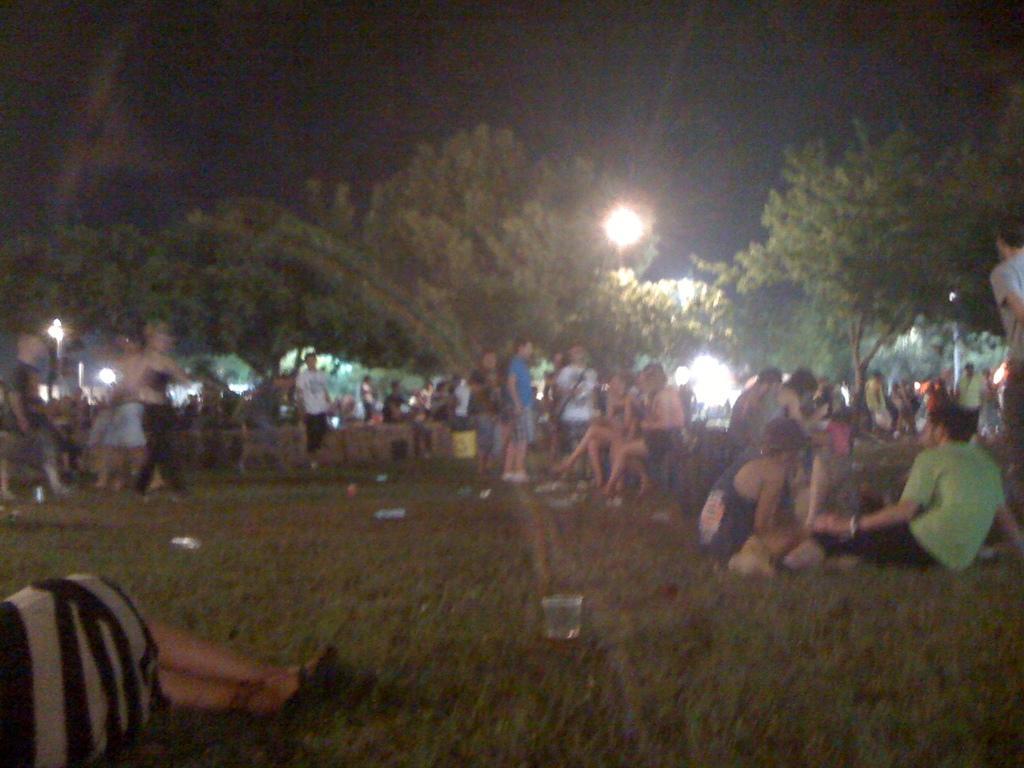How would you summarize this image in a sentence or two? In the center of the image we can see a group of people, trees, light, chains are present. At the bottom of the image we can see a glass, ground are there. At the top of the image sky is there. 